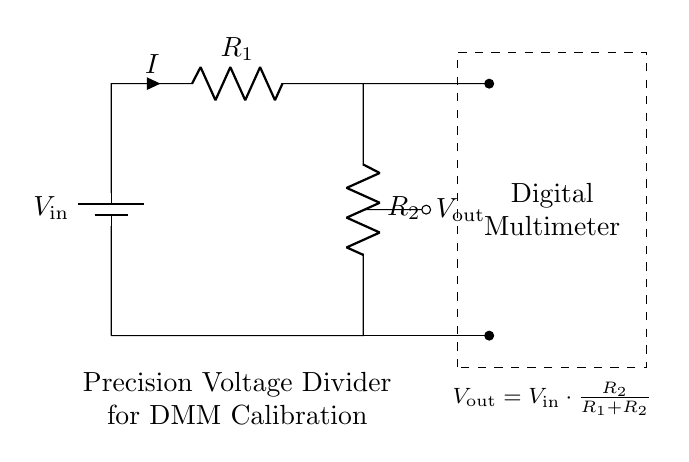What are the resistances in the circuit? The circuit has two resistors labeled R1 and R2, which are the two components of the voltage divider.
Answer: R1, R2 What is the output voltage formula? The formula for the output voltage in a voltage divider is given in the diagram as Vout = Vin * (R2 / (R1 + R2)).
Answer: Vout = Vin * (R2 / (R1 + R2)) Which direction does the current flow? The current flows from the positive terminal of Vin, through R1, then through R2, and back to the negative terminal of Vin.
Answer: From Vin to R1 to R2 What is the purpose of this circuit? The purpose of this circuit is to act as a precision voltage divider for calibrating digital multimeters in electronic repair projects.
Answer: Calibration If R1 = 1k ohm and R2 = 2k ohm, what is the ratio of the resistances? The ratio of the resistances R2 to R1 is calculated as R2 / R1 = 2k / 1k, which equals 2.
Answer: 2 What kind of device is indicated in the dashed rectangle? The dashed rectangle indicates a digital multimeter, which is used for measuring the output voltage of the divider circuit.
Answer: Digital multimeter What is the input voltage denoted as in the diagram? The input voltage is denoted as Vin in the circuit, indicating the voltage supplied to the divider.
Answer: Vin 